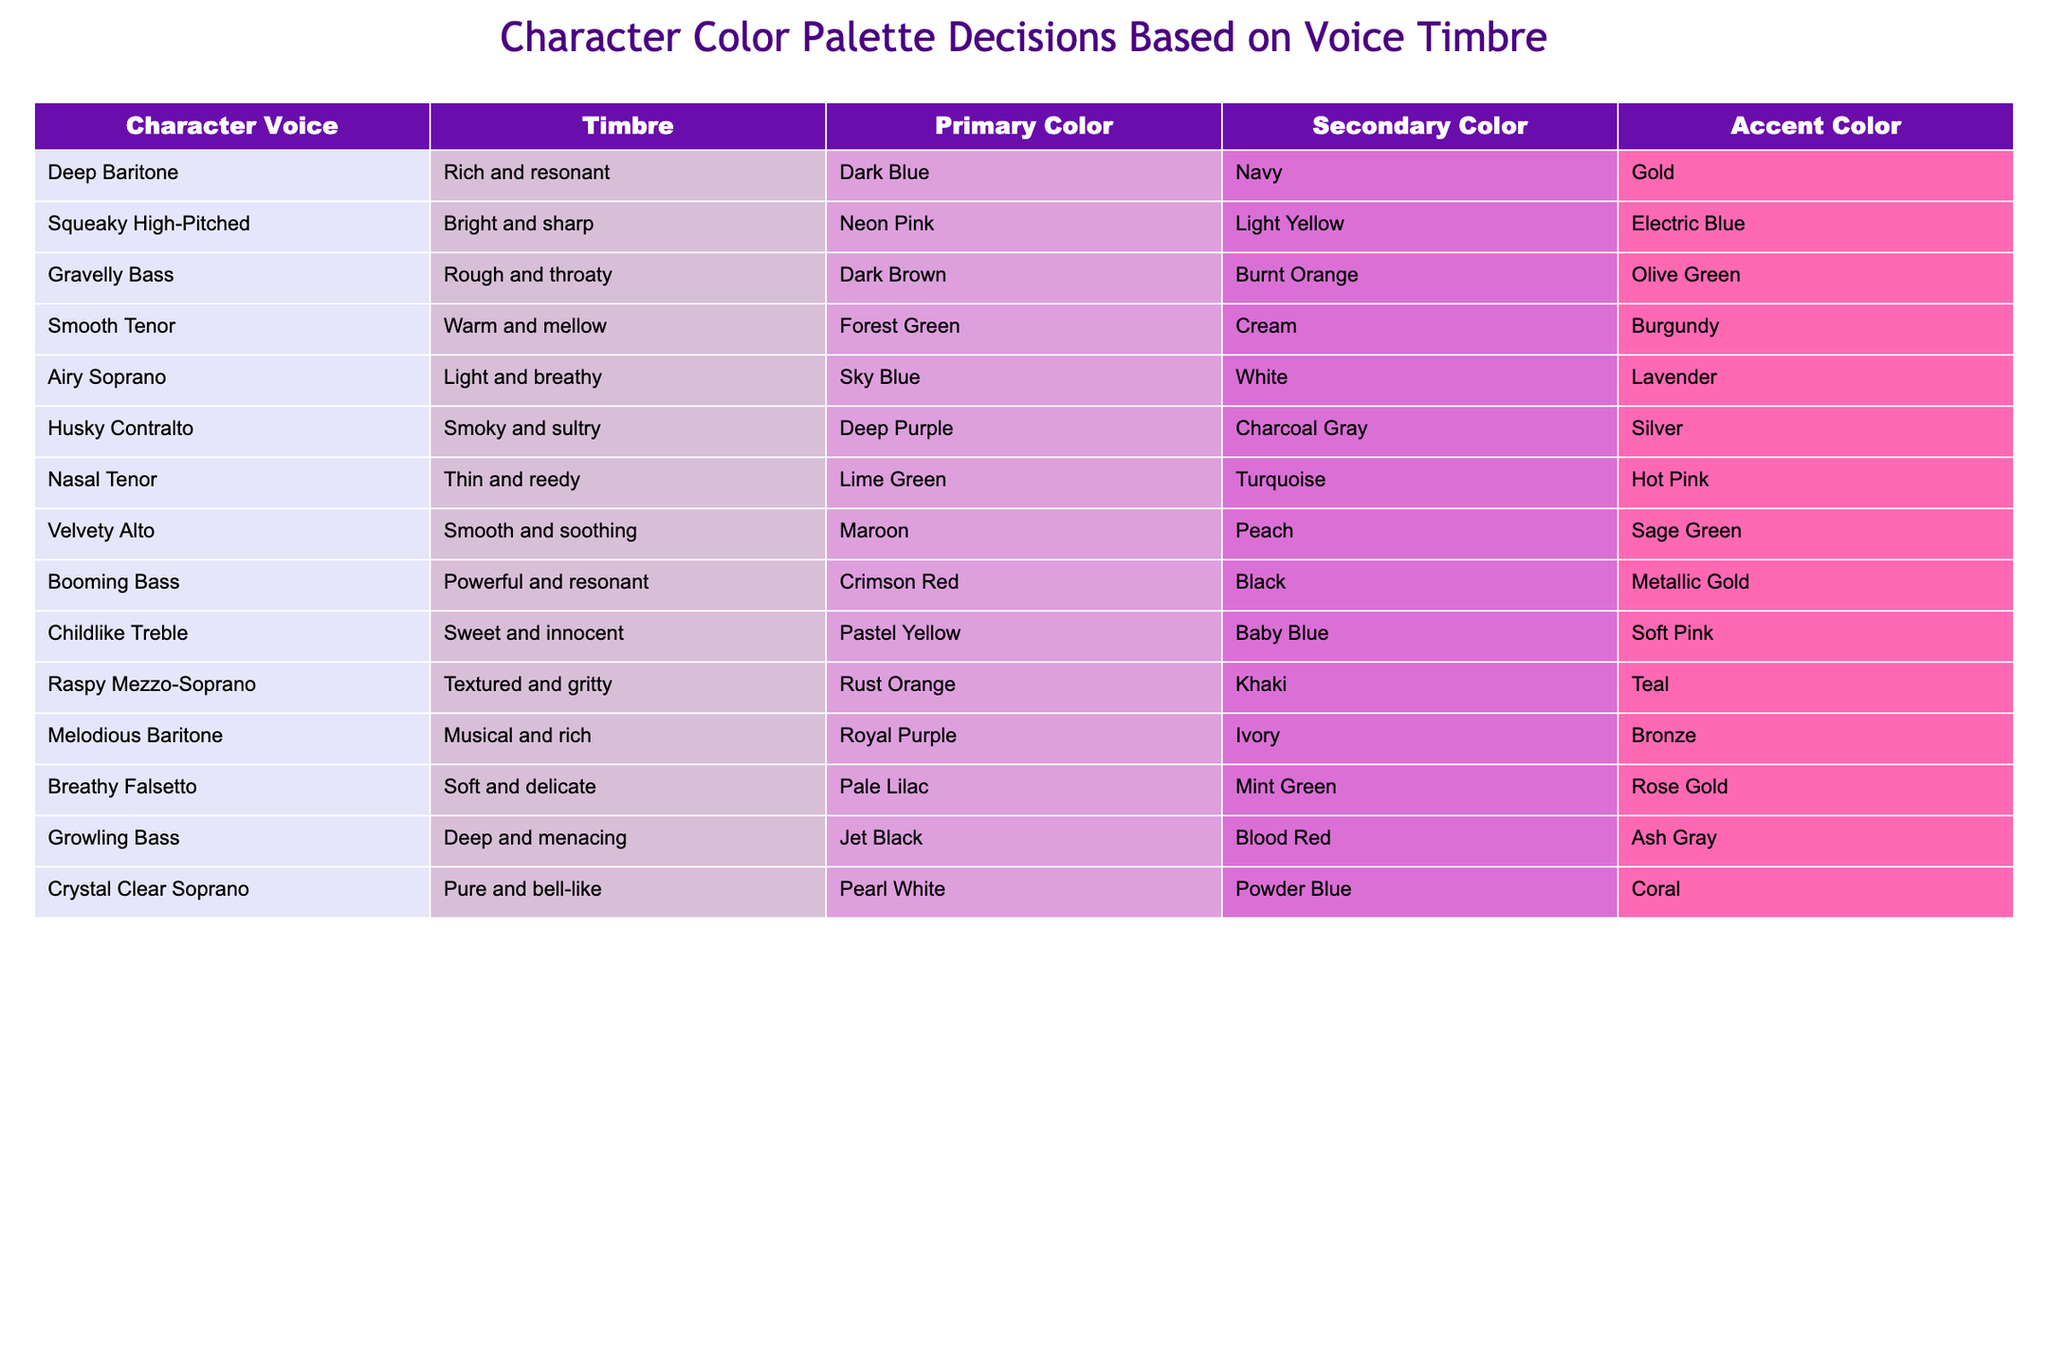What is the primary color for the character with a gravelly bass voice? The table shows that the character with a gravelly bass voice has a primary color of dark brown. This information is directly listed in the corresponding row for gravelly bass.
Answer: Dark Brown Which character has a secondary color of baby blue? Referring to the table, the character with a secondary color of baby blue is the childlike treble. This is specifically indicated in the respective row.
Answer: Childlike Treble Is the accent color for the smooth tenor character silver? The table lists the accent color for the smooth tenor as burgundy, not silver. Therefore, the statement is false based on the provided data.
Answer: No What is the average length of the primary colors that are classified as dark? The primary colors classified as dark are: dark blue, dark brown, and jet black. Counting the characters: dark blue has 8 letters, dark brown has 10 letters, and jet black has 8 letters. Adding these gives: 8 + 10 + 8 = 26. Dividing by the count of 3 gives an average of 26/3 ≈ 8.67.
Answer: 8.67 Which characters have a secondary color of gray? A review of the table shows that the husky contralto has a secondary color of charcoal gray, and the growling bass has ash gray. This information requires scanning the table for gray-related colors and identifying the corresponding characters.
Answer: Husky Contralto, Growling Bass What is the accent color for the booming bass character? The table specifies that the booming bass character has an accent color of metallic gold, indicated clearly in this character’s designated row.
Answer: Metallic Gold Do any characters feature pastel yellow as a primary color? Scanning the table, there are no characters listed with pastel yellow as a primary color, confirming the statement is false.
Answer: No What is the unique color palette combination for the raspy mezzo-soprano character? For the raspy mezzo-soprano, the table indicates that the primary color is rust orange, the secondary color is khaki, and the accent color is teal. This provides a complete view of the character’s color palette based on the table data.
Answer: Rust Orange, Khaki, Teal 